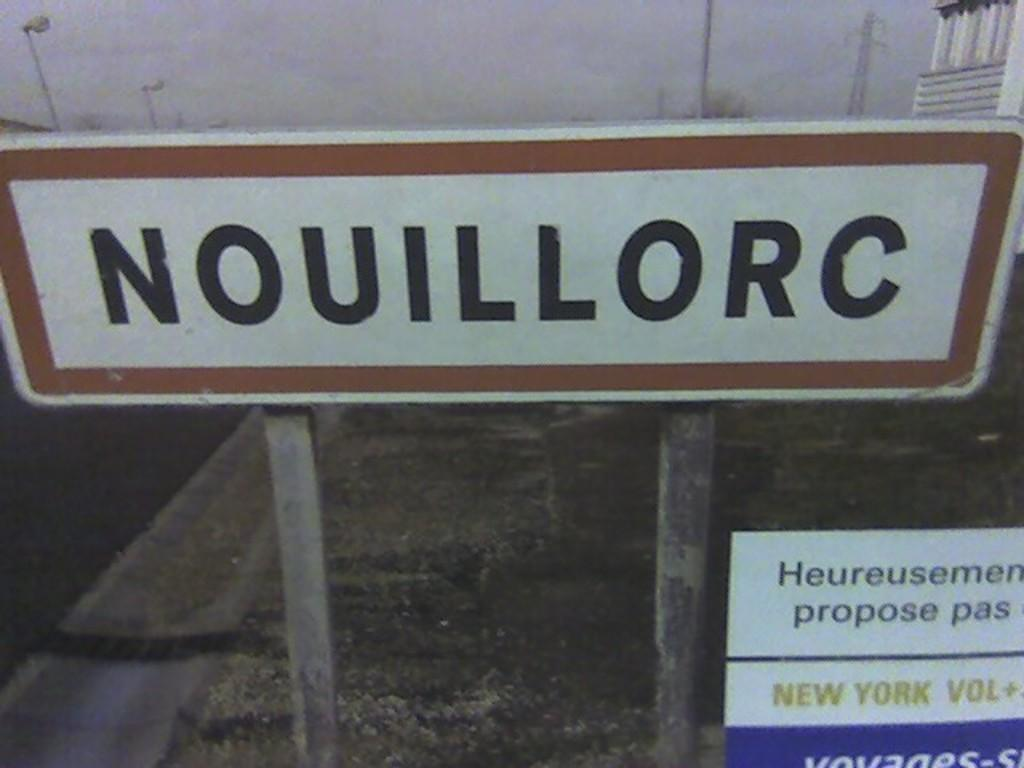<image>
Share a concise interpretation of the image provided. A sign on wooden posts says NOUILLORC in black writing. 